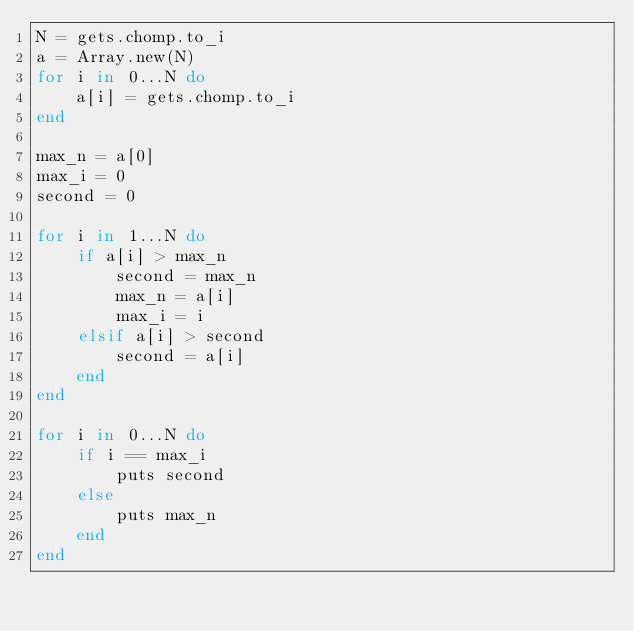Convert code to text. <code><loc_0><loc_0><loc_500><loc_500><_Ruby_>N = gets.chomp.to_i
a = Array.new(N)
for i in 0...N do
    a[i] = gets.chomp.to_i
end

max_n = a[0]
max_i = 0
second = 0

for i in 1...N do
    if a[i] > max_n
        second = max_n
        max_n = a[i]
        max_i = i
    elsif a[i] > second
        second = a[i]
    end
end

for i in 0...N do
    if i == max_i
        puts second
    else
        puts max_n
    end
end</code> 